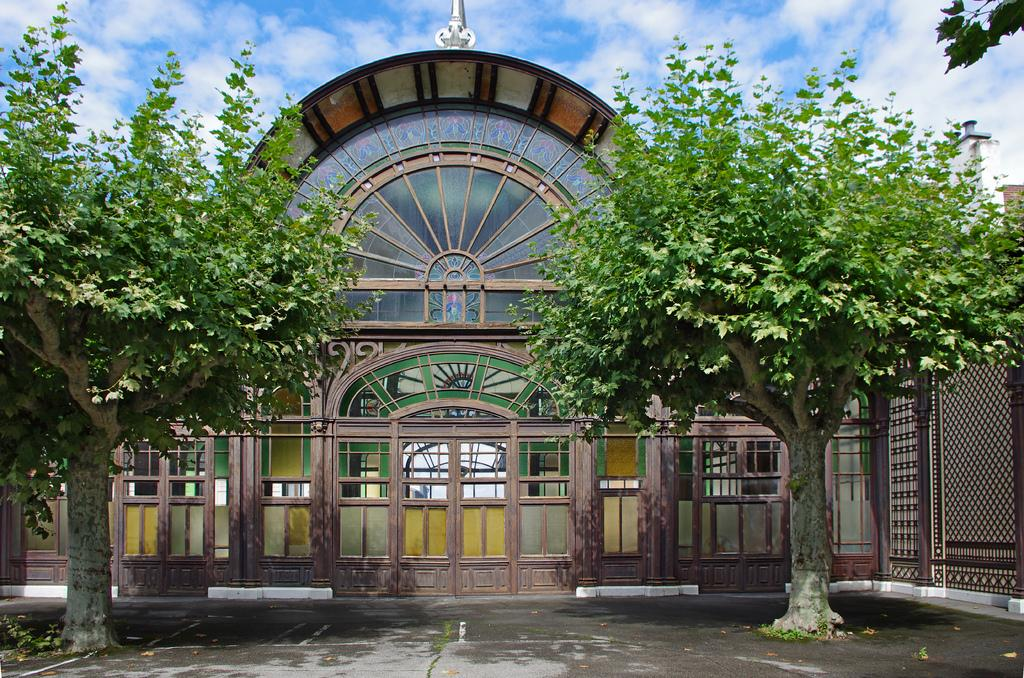What type of structure is present in the image? There is a building in the image. What other natural elements can be seen in the image? There are trees in the image. What can be seen in the distance in the image? The sky is visible in the background of the image. How much salt is present on the trees in the image? There is no salt present on the trees in the image, as salt is not a natural component of trees. 